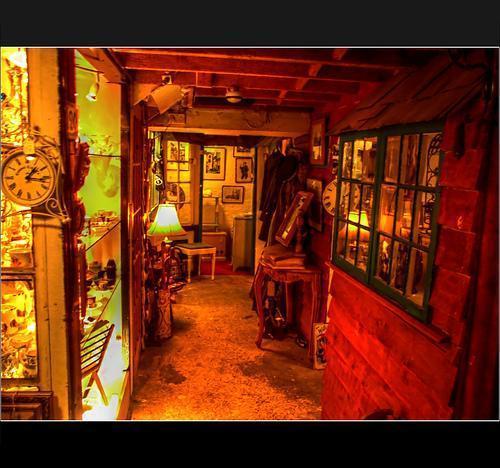How many people are in the picture?
Give a very brief answer. 0. 